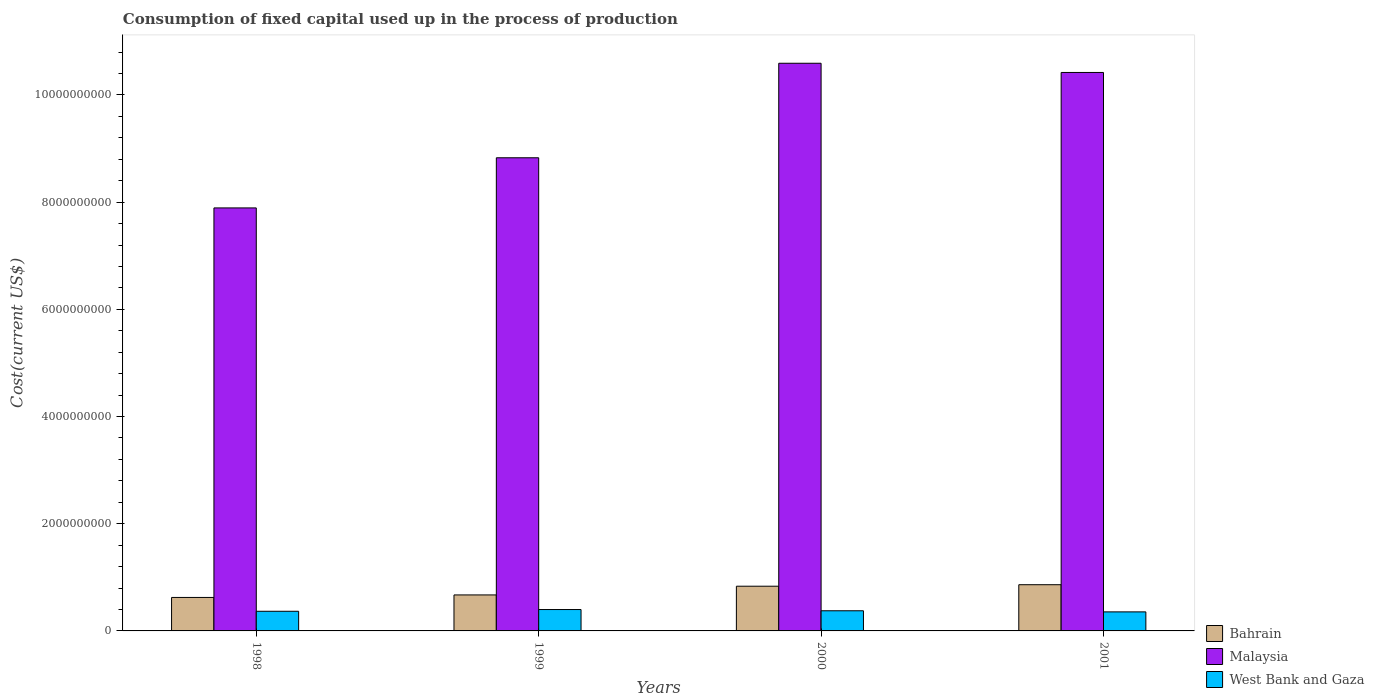How many different coloured bars are there?
Make the answer very short. 3. Are the number of bars on each tick of the X-axis equal?
Offer a very short reply. Yes. What is the amount consumed in the process of production in Bahrain in 1999?
Your answer should be very brief. 6.72e+08. Across all years, what is the maximum amount consumed in the process of production in Bahrain?
Provide a short and direct response. 8.62e+08. Across all years, what is the minimum amount consumed in the process of production in West Bank and Gaza?
Offer a terse response. 3.55e+08. In which year was the amount consumed in the process of production in West Bank and Gaza maximum?
Offer a very short reply. 1999. In which year was the amount consumed in the process of production in West Bank and Gaza minimum?
Make the answer very short. 2001. What is the total amount consumed in the process of production in Bahrain in the graph?
Your answer should be compact. 2.99e+09. What is the difference between the amount consumed in the process of production in Malaysia in 1999 and that in 2001?
Provide a short and direct response. -1.59e+09. What is the difference between the amount consumed in the process of production in West Bank and Gaza in 2000 and the amount consumed in the process of production in Malaysia in 1998?
Make the answer very short. -7.52e+09. What is the average amount consumed in the process of production in Bahrain per year?
Keep it short and to the point. 7.48e+08. In the year 1999, what is the difference between the amount consumed in the process of production in Bahrain and amount consumed in the process of production in West Bank and Gaza?
Your answer should be compact. 2.73e+08. In how many years, is the amount consumed in the process of production in Bahrain greater than 3600000000 US$?
Provide a succinct answer. 0. What is the ratio of the amount consumed in the process of production in Malaysia in 1999 to that in 2000?
Provide a succinct answer. 0.83. Is the amount consumed in the process of production in Malaysia in 1998 less than that in 2000?
Provide a short and direct response. Yes. What is the difference between the highest and the second highest amount consumed in the process of production in Malaysia?
Offer a very short reply. 1.72e+08. What is the difference between the highest and the lowest amount consumed in the process of production in Bahrain?
Make the answer very short. 2.38e+08. What does the 1st bar from the left in 2001 represents?
Make the answer very short. Bahrain. What does the 1st bar from the right in 1998 represents?
Your answer should be compact. West Bank and Gaza. Is it the case that in every year, the sum of the amount consumed in the process of production in West Bank and Gaza and amount consumed in the process of production in Malaysia is greater than the amount consumed in the process of production in Bahrain?
Provide a short and direct response. Yes. How many bars are there?
Provide a short and direct response. 12. Are all the bars in the graph horizontal?
Make the answer very short. No. Does the graph contain any zero values?
Your response must be concise. No. Does the graph contain grids?
Keep it short and to the point. No. Where does the legend appear in the graph?
Offer a terse response. Bottom right. How many legend labels are there?
Offer a very short reply. 3. How are the legend labels stacked?
Give a very brief answer. Vertical. What is the title of the graph?
Provide a short and direct response. Consumption of fixed capital used up in the process of production. What is the label or title of the X-axis?
Make the answer very short. Years. What is the label or title of the Y-axis?
Offer a terse response. Cost(current US$). What is the Cost(current US$) in Bahrain in 1998?
Provide a succinct answer. 6.25e+08. What is the Cost(current US$) of Malaysia in 1998?
Offer a terse response. 7.89e+09. What is the Cost(current US$) of West Bank and Gaza in 1998?
Provide a short and direct response. 3.67e+08. What is the Cost(current US$) in Bahrain in 1999?
Offer a very short reply. 6.72e+08. What is the Cost(current US$) of Malaysia in 1999?
Provide a succinct answer. 8.83e+09. What is the Cost(current US$) of West Bank and Gaza in 1999?
Provide a succinct answer. 3.99e+08. What is the Cost(current US$) in Bahrain in 2000?
Ensure brevity in your answer.  8.34e+08. What is the Cost(current US$) of Malaysia in 2000?
Provide a short and direct response. 1.06e+1. What is the Cost(current US$) in West Bank and Gaza in 2000?
Your response must be concise. 3.76e+08. What is the Cost(current US$) in Bahrain in 2001?
Provide a short and direct response. 8.62e+08. What is the Cost(current US$) of Malaysia in 2001?
Provide a short and direct response. 1.04e+1. What is the Cost(current US$) of West Bank and Gaza in 2001?
Provide a short and direct response. 3.55e+08. Across all years, what is the maximum Cost(current US$) in Bahrain?
Keep it short and to the point. 8.62e+08. Across all years, what is the maximum Cost(current US$) in Malaysia?
Your response must be concise. 1.06e+1. Across all years, what is the maximum Cost(current US$) in West Bank and Gaza?
Give a very brief answer. 3.99e+08. Across all years, what is the minimum Cost(current US$) in Bahrain?
Offer a very short reply. 6.25e+08. Across all years, what is the minimum Cost(current US$) in Malaysia?
Your answer should be very brief. 7.89e+09. Across all years, what is the minimum Cost(current US$) in West Bank and Gaza?
Your answer should be compact. 3.55e+08. What is the total Cost(current US$) in Bahrain in the graph?
Make the answer very short. 2.99e+09. What is the total Cost(current US$) of Malaysia in the graph?
Make the answer very short. 3.77e+1. What is the total Cost(current US$) of West Bank and Gaza in the graph?
Your response must be concise. 1.50e+09. What is the difference between the Cost(current US$) in Bahrain in 1998 and that in 1999?
Offer a terse response. -4.70e+07. What is the difference between the Cost(current US$) of Malaysia in 1998 and that in 1999?
Give a very brief answer. -9.36e+08. What is the difference between the Cost(current US$) of West Bank and Gaza in 1998 and that in 1999?
Make the answer very short. -3.24e+07. What is the difference between the Cost(current US$) in Bahrain in 1998 and that in 2000?
Ensure brevity in your answer.  -2.09e+08. What is the difference between the Cost(current US$) in Malaysia in 1998 and that in 2000?
Your answer should be compact. -2.70e+09. What is the difference between the Cost(current US$) of West Bank and Gaza in 1998 and that in 2000?
Give a very brief answer. -9.32e+06. What is the difference between the Cost(current US$) of Bahrain in 1998 and that in 2001?
Your answer should be compact. -2.38e+08. What is the difference between the Cost(current US$) in Malaysia in 1998 and that in 2001?
Your answer should be very brief. -2.53e+09. What is the difference between the Cost(current US$) of West Bank and Gaza in 1998 and that in 2001?
Make the answer very short. 1.14e+07. What is the difference between the Cost(current US$) of Bahrain in 1999 and that in 2000?
Provide a succinct answer. -1.62e+08. What is the difference between the Cost(current US$) in Malaysia in 1999 and that in 2000?
Offer a very short reply. -1.76e+09. What is the difference between the Cost(current US$) of West Bank and Gaza in 1999 and that in 2000?
Ensure brevity in your answer.  2.30e+07. What is the difference between the Cost(current US$) in Bahrain in 1999 and that in 2001?
Provide a short and direct response. -1.91e+08. What is the difference between the Cost(current US$) of Malaysia in 1999 and that in 2001?
Keep it short and to the point. -1.59e+09. What is the difference between the Cost(current US$) of West Bank and Gaza in 1999 and that in 2001?
Give a very brief answer. 4.38e+07. What is the difference between the Cost(current US$) of Bahrain in 2000 and that in 2001?
Offer a terse response. -2.81e+07. What is the difference between the Cost(current US$) in Malaysia in 2000 and that in 2001?
Offer a very short reply. 1.72e+08. What is the difference between the Cost(current US$) in West Bank and Gaza in 2000 and that in 2001?
Make the answer very short. 2.07e+07. What is the difference between the Cost(current US$) in Bahrain in 1998 and the Cost(current US$) in Malaysia in 1999?
Your answer should be very brief. -8.20e+09. What is the difference between the Cost(current US$) of Bahrain in 1998 and the Cost(current US$) of West Bank and Gaza in 1999?
Give a very brief answer. 2.26e+08. What is the difference between the Cost(current US$) in Malaysia in 1998 and the Cost(current US$) in West Bank and Gaza in 1999?
Keep it short and to the point. 7.49e+09. What is the difference between the Cost(current US$) of Bahrain in 1998 and the Cost(current US$) of Malaysia in 2000?
Offer a very short reply. -9.97e+09. What is the difference between the Cost(current US$) of Bahrain in 1998 and the Cost(current US$) of West Bank and Gaza in 2000?
Your answer should be very brief. 2.49e+08. What is the difference between the Cost(current US$) in Malaysia in 1998 and the Cost(current US$) in West Bank and Gaza in 2000?
Your answer should be compact. 7.52e+09. What is the difference between the Cost(current US$) in Bahrain in 1998 and the Cost(current US$) in Malaysia in 2001?
Your response must be concise. -9.80e+09. What is the difference between the Cost(current US$) in Bahrain in 1998 and the Cost(current US$) in West Bank and Gaza in 2001?
Your answer should be very brief. 2.69e+08. What is the difference between the Cost(current US$) of Malaysia in 1998 and the Cost(current US$) of West Bank and Gaza in 2001?
Offer a very short reply. 7.54e+09. What is the difference between the Cost(current US$) in Bahrain in 1999 and the Cost(current US$) in Malaysia in 2000?
Make the answer very short. -9.92e+09. What is the difference between the Cost(current US$) of Bahrain in 1999 and the Cost(current US$) of West Bank and Gaza in 2000?
Provide a succinct answer. 2.96e+08. What is the difference between the Cost(current US$) in Malaysia in 1999 and the Cost(current US$) in West Bank and Gaza in 2000?
Ensure brevity in your answer.  8.45e+09. What is the difference between the Cost(current US$) of Bahrain in 1999 and the Cost(current US$) of Malaysia in 2001?
Ensure brevity in your answer.  -9.75e+09. What is the difference between the Cost(current US$) in Bahrain in 1999 and the Cost(current US$) in West Bank and Gaza in 2001?
Offer a terse response. 3.16e+08. What is the difference between the Cost(current US$) of Malaysia in 1999 and the Cost(current US$) of West Bank and Gaza in 2001?
Offer a very short reply. 8.47e+09. What is the difference between the Cost(current US$) of Bahrain in 2000 and the Cost(current US$) of Malaysia in 2001?
Your answer should be compact. -9.59e+09. What is the difference between the Cost(current US$) of Bahrain in 2000 and the Cost(current US$) of West Bank and Gaza in 2001?
Your answer should be compact. 4.79e+08. What is the difference between the Cost(current US$) of Malaysia in 2000 and the Cost(current US$) of West Bank and Gaza in 2001?
Offer a terse response. 1.02e+1. What is the average Cost(current US$) in Bahrain per year?
Ensure brevity in your answer.  7.48e+08. What is the average Cost(current US$) of Malaysia per year?
Offer a terse response. 9.43e+09. What is the average Cost(current US$) of West Bank and Gaza per year?
Ensure brevity in your answer.  3.74e+08. In the year 1998, what is the difference between the Cost(current US$) in Bahrain and Cost(current US$) in Malaysia?
Provide a succinct answer. -7.27e+09. In the year 1998, what is the difference between the Cost(current US$) in Bahrain and Cost(current US$) in West Bank and Gaza?
Your answer should be very brief. 2.58e+08. In the year 1998, what is the difference between the Cost(current US$) of Malaysia and Cost(current US$) of West Bank and Gaza?
Offer a terse response. 7.53e+09. In the year 1999, what is the difference between the Cost(current US$) in Bahrain and Cost(current US$) in Malaysia?
Your answer should be very brief. -8.16e+09. In the year 1999, what is the difference between the Cost(current US$) of Bahrain and Cost(current US$) of West Bank and Gaza?
Ensure brevity in your answer.  2.73e+08. In the year 1999, what is the difference between the Cost(current US$) of Malaysia and Cost(current US$) of West Bank and Gaza?
Offer a very short reply. 8.43e+09. In the year 2000, what is the difference between the Cost(current US$) in Bahrain and Cost(current US$) in Malaysia?
Offer a terse response. -9.76e+09. In the year 2000, what is the difference between the Cost(current US$) of Bahrain and Cost(current US$) of West Bank and Gaza?
Provide a succinct answer. 4.58e+08. In the year 2000, what is the difference between the Cost(current US$) of Malaysia and Cost(current US$) of West Bank and Gaza?
Ensure brevity in your answer.  1.02e+1. In the year 2001, what is the difference between the Cost(current US$) in Bahrain and Cost(current US$) in Malaysia?
Make the answer very short. -9.56e+09. In the year 2001, what is the difference between the Cost(current US$) of Bahrain and Cost(current US$) of West Bank and Gaza?
Your answer should be compact. 5.07e+08. In the year 2001, what is the difference between the Cost(current US$) of Malaysia and Cost(current US$) of West Bank and Gaza?
Ensure brevity in your answer.  1.01e+1. What is the ratio of the Cost(current US$) in Malaysia in 1998 to that in 1999?
Your response must be concise. 0.89. What is the ratio of the Cost(current US$) of West Bank and Gaza in 1998 to that in 1999?
Provide a short and direct response. 0.92. What is the ratio of the Cost(current US$) in Bahrain in 1998 to that in 2000?
Offer a very short reply. 0.75. What is the ratio of the Cost(current US$) in Malaysia in 1998 to that in 2000?
Your answer should be very brief. 0.75. What is the ratio of the Cost(current US$) in West Bank and Gaza in 1998 to that in 2000?
Your response must be concise. 0.98. What is the ratio of the Cost(current US$) of Bahrain in 1998 to that in 2001?
Offer a terse response. 0.72. What is the ratio of the Cost(current US$) of Malaysia in 1998 to that in 2001?
Ensure brevity in your answer.  0.76. What is the ratio of the Cost(current US$) of West Bank and Gaza in 1998 to that in 2001?
Offer a terse response. 1.03. What is the ratio of the Cost(current US$) of Bahrain in 1999 to that in 2000?
Provide a short and direct response. 0.81. What is the ratio of the Cost(current US$) in Malaysia in 1999 to that in 2000?
Your answer should be very brief. 0.83. What is the ratio of the Cost(current US$) in West Bank and Gaza in 1999 to that in 2000?
Provide a short and direct response. 1.06. What is the ratio of the Cost(current US$) in Bahrain in 1999 to that in 2001?
Keep it short and to the point. 0.78. What is the ratio of the Cost(current US$) of Malaysia in 1999 to that in 2001?
Give a very brief answer. 0.85. What is the ratio of the Cost(current US$) of West Bank and Gaza in 1999 to that in 2001?
Make the answer very short. 1.12. What is the ratio of the Cost(current US$) of Bahrain in 2000 to that in 2001?
Offer a terse response. 0.97. What is the ratio of the Cost(current US$) of Malaysia in 2000 to that in 2001?
Your answer should be very brief. 1.02. What is the ratio of the Cost(current US$) in West Bank and Gaza in 2000 to that in 2001?
Provide a succinct answer. 1.06. What is the difference between the highest and the second highest Cost(current US$) in Bahrain?
Ensure brevity in your answer.  2.81e+07. What is the difference between the highest and the second highest Cost(current US$) in Malaysia?
Make the answer very short. 1.72e+08. What is the difference between the highest and the second highest Cost(current US$) in West Bank and Gaza?
Offer a terse response. 2.30e+07. What is the difference between the highest and the lowest Cost(current US$) in Bahrain?
Give a very brief answer. 2.38e+08. What is the difference between the highest and the lowest Cost(current US$) in Malaysia?
Offer a terse response. 2.70e+09. What is the difference between the highest and the lowest Cost(current US$) in West Bank and Gaza?
Give a very brief answer. 4.38e+07. 